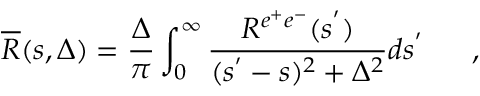Convert formula to latex. <formula><loc_0><loc_0><loc_500><loc_500>\overline { R } ( s , \Delta ) = \frac { \Delta } { \pi } \int _ { 0 } ^ { \infty } \frac { R ^ { e ^ { + } e ^ { - } } ( s ^ { ^ { \prime } } ) } { ( s ^ { ^ { \prime } } - s ) ^ { 2 } + \Delta ^ { 2 } } d s ^ { ^ { \prime } } ,</formula> 